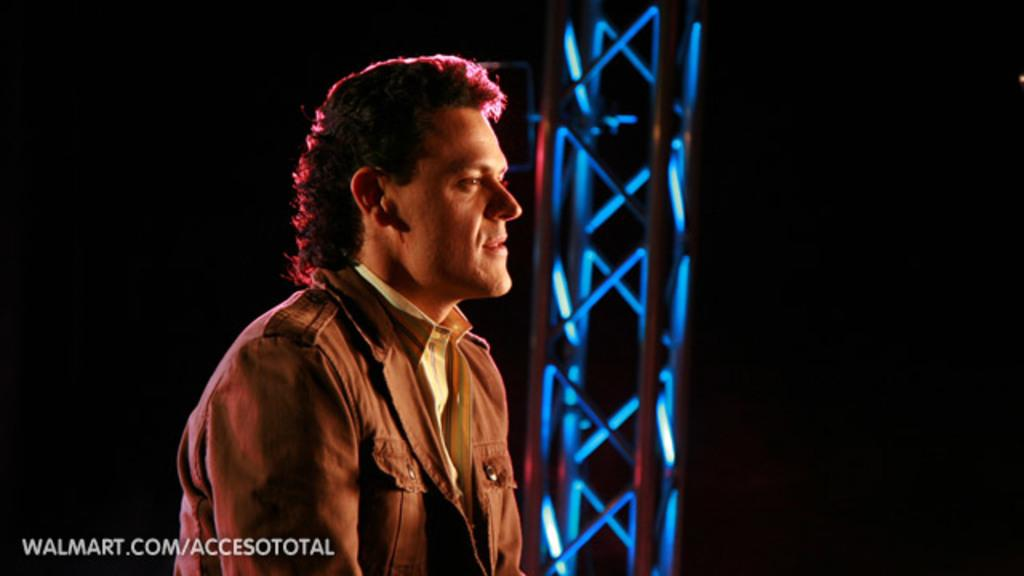What is the person in the image wearing? There is a person wearing a dress in the image. What can be seen on the right side of the image? There is a metal frame on the right side of the image. Is there any text visible in the image? Yes, there is some text visible at the bottom of the image. How many hens are present in the image? There are no hens present in the image. What type of insurance is being advertised in the image? There is no insurance being advertised in the image. 